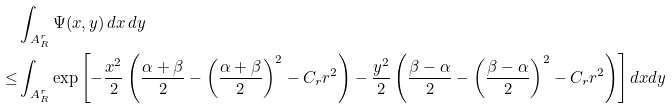Convert formula to latex. <formula><loc_0><loc_0><loc_500><loc_500>& \int _ { A _ { R } ^ { r } } \Psi ( x , y ) \, d x \, d y \\ \leq & \int _ { A _ { R } ^ { r } } \exp \left [ - \frac { x ^ { 2 } } { 2 } \left ( \frac { \alpha + \beta } { 2 } - \left ( \frac { \alpha + \beta } { 2 } \right ) ^ { 2 } - C _ { r } r ^ { 2 } \right ) - \frac { y ^ { 2 } } { 2 } \left ( \frac { \beta - \alpha } { 2 } - \left ( \frac { \beta - \alpha } { 2 } \right ) ^ { 2 } - C _ { r } r ^ { 2 } \right ) \right ] d x d y</formula> 